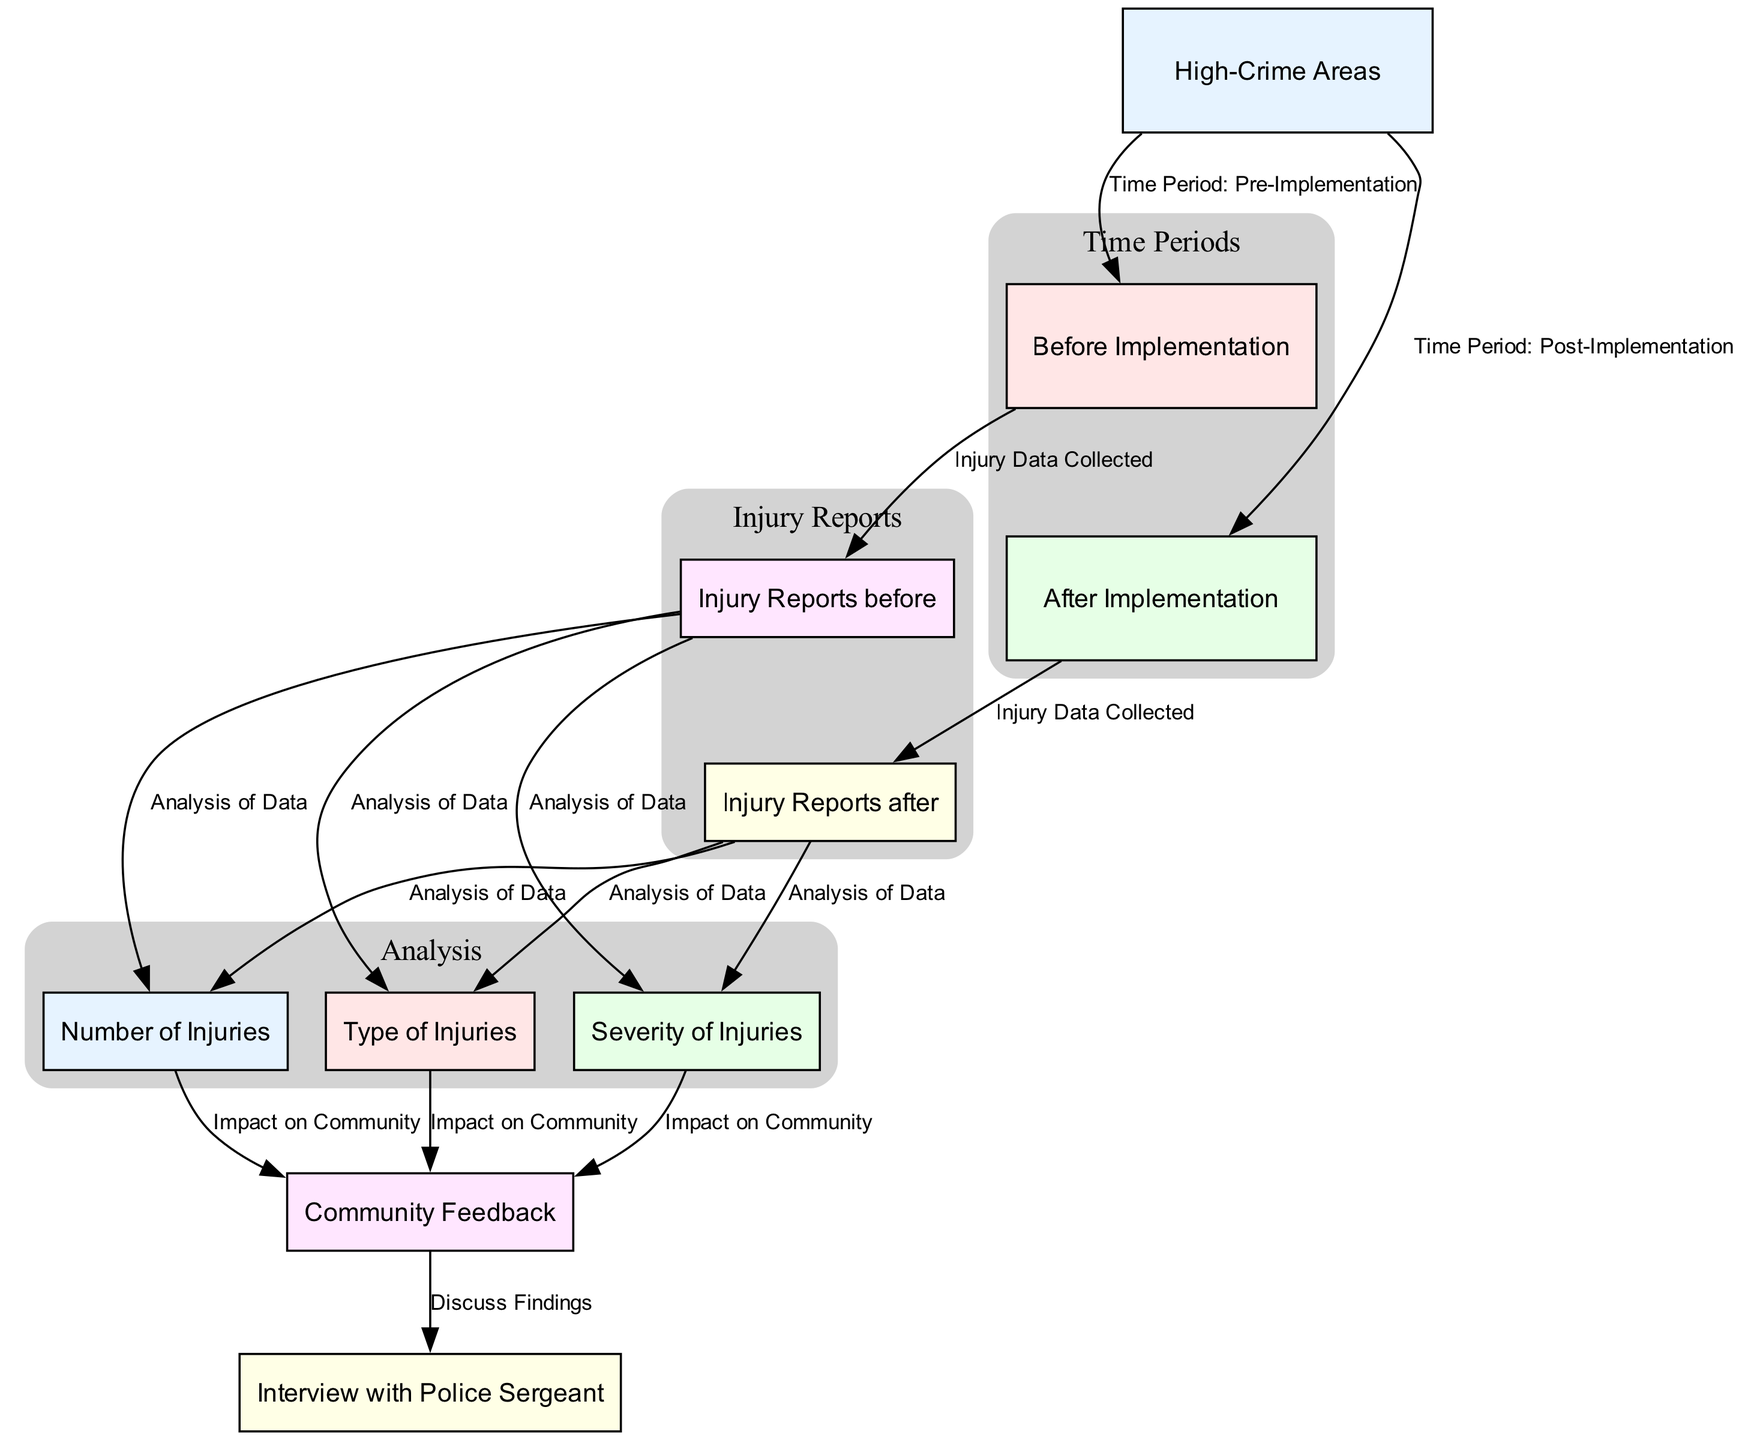What are the two time periods represented in the diagram? The diagram shows two distinct time periods labeled as "Before Implementation" and "After Implementation." These are connected to the "High-Crime Areas" node, representing the timeframe of the injury reports.
Answer: Before Implementation, After Implementation What type of data is collected before the implementation? The diagram indicates that injury reports are collected in the "Before Implementation" node, specifically illustrated by the edges leading to the "Injury Reports before" node.
Answer: Injury Reports before What analysis is performed on the injury reports after implementation? After the implementation of new security measures, the report states that similar analyses are conducted on the "Injury Reports after" node, as reflected by the edges connecting to number, type, and severity of injuries.
Answer: Analysis of Data How do the number of injuries relate to community feedback? The diagram shows that there are connections from the "Number of Injuries" node to "Community Feedback," indicating that the number of injuries directly impacts how the community perceives the situation following security measure implementations.
Answer: Impact on Community What does the node "Discuss Findings" signify? The "Discuss Findings" node indicates that community feedback about injuries leads to discussions, perhaps for future improvements or understanding impacts, as shown by its connections from the "Community Feedback" node.
Answer: Discuss Findings How many analysis categories are present in the injury report sections? There are three analysis categories illustrated in the diagram, which include "Number of Injuries," "Type of Injuries," and "Severity of Injuries." Each links to both the before and after sections of the report.
Answer: Three What is the relationship between "Injury Reports before" and "Injury Reports after"? The diagram depicts that both the "Injury Reports before" and "Injury Reports after" are connected to their respective nodes under the same "High-Crime Areas," denoting a sequential comparison of data.
Answer: Time Period Comparison What is the main focus of the diagram? The primary focus of the diagram is on visualizing the changes in injury reports resulting from the implementation of new security measures in high-crime areas. This encompasses the community's feedback and the partnership with law enforcement highlighted by the final node.
Answer: Visualization of Changes 